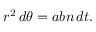<formula> <loc_0><loc_0><loc_500><loc_500>r ^ { 2 } \, d \theta = a b n \, d t .</formula> 